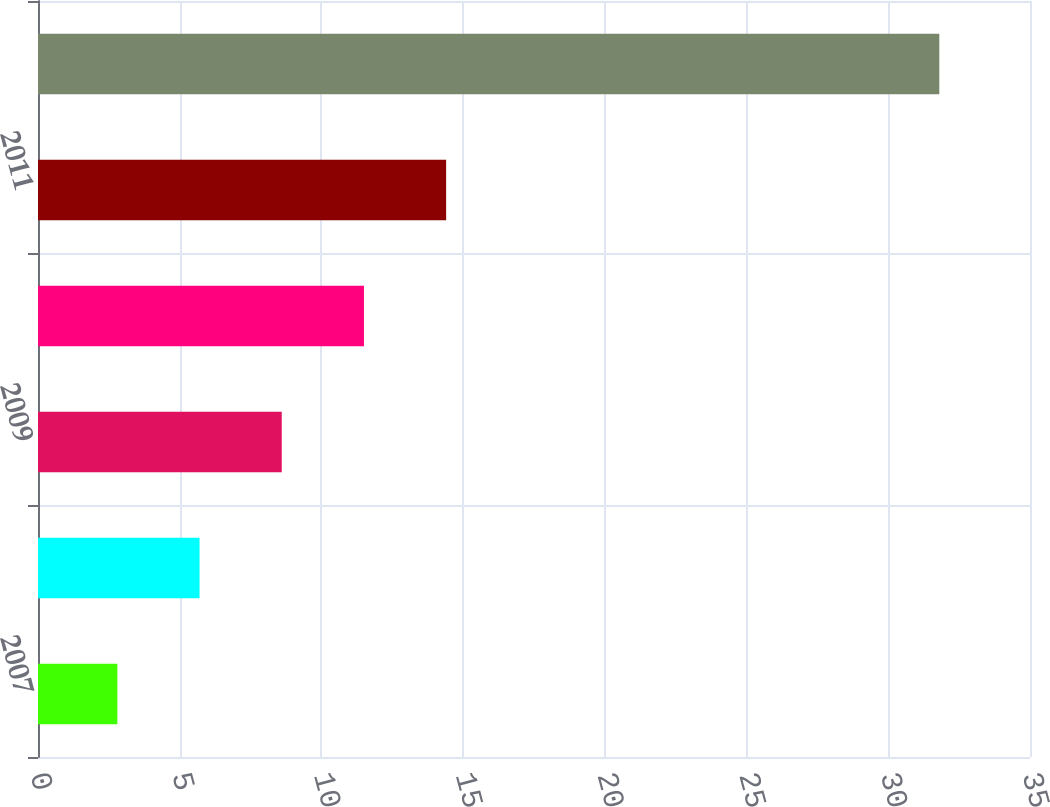Convert chart to OTSL. <chart><loc_0><loc_0><loc_500><loc_500><bar_chart><fcel>2007<fcel>2008<fcel>2009<fcel>2010<fcel>2011<fcel>Years 2012-2016<nl><fcel>2.8<fcel>5.7<fcel>8.6<fcel>11.5<fcel>14.4<fcel>31.8<nl></chart> 